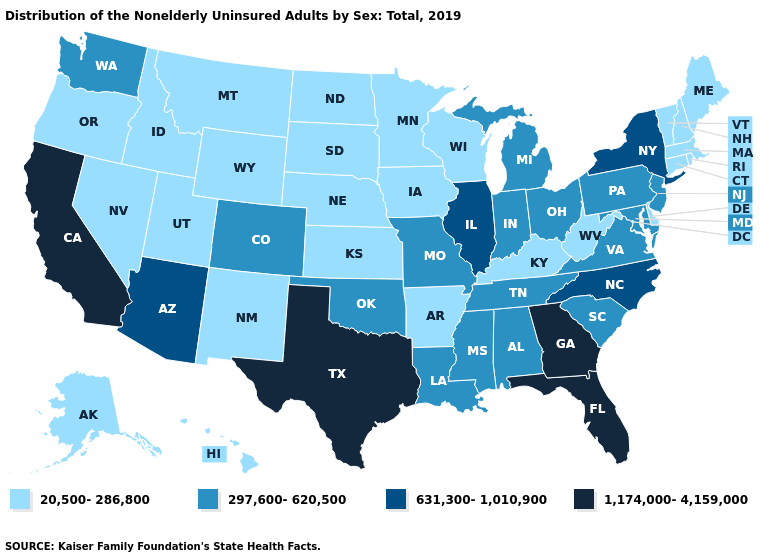Among the states that border Kansas , which have the highest value?
Give a very brief answer. Colorado, Missouri, Oklahoma. Does Ohio have the same value as Virginia?
Be succinct. Yes. Does Nebraska have the highest value in the MidWest?
Be succinct. No. Does Michigan have the lowest value in the MidWest?
Short answer required. No. Among the states that border Alabama , which have the highest value?
Keep it brief. Florida, Georgia. How many symbols are there in the legend?
Answer briefly. 4. How many symbols are there in the legend?
Give a very brief answer. 4. Name the states that have a value in the range 297,600-620,500?
Short answer required. Alabama, Colorado, Indiana, Louisiana, Maryland, Michigan, Mississippi, Missouri, New Jersey, Ohio, Oklahoma, Pennsylvania, South Carolina, Tennessee, Virginia, Washington. Name the states that have a value in the range 297,600-620,500?
Short answer required. Alabama, Colorado, Indiana, Louisiana, Maryland, Michigan, Mississippi, Missouri, New Jersey, Ohio, Oklahoma, Pennsylvania, South Carolina, Tennessee, Virginia, Washington. Name the states that have a value in the range 297,600-620,500?
Be succinct. Alabama, Colorado, Indiana, Louisiana, Maryland, Michigan, Mississippi, Missouri, New Jersey, Ohio, Oklahoma, Pennsylvania, South Carolina, Tennessee, Virginia, Washington. What is the lowest value in the Northeast?
Concise answer only. 20,500-286,800. What is the value of New York?
Quick response, please. 631,300-1,010,900. Does Minnesota have the lowest value in the USA?
Answer briefly. Yes. What is the value of Vermont?
Answer briefly. 20,500-286,800. 